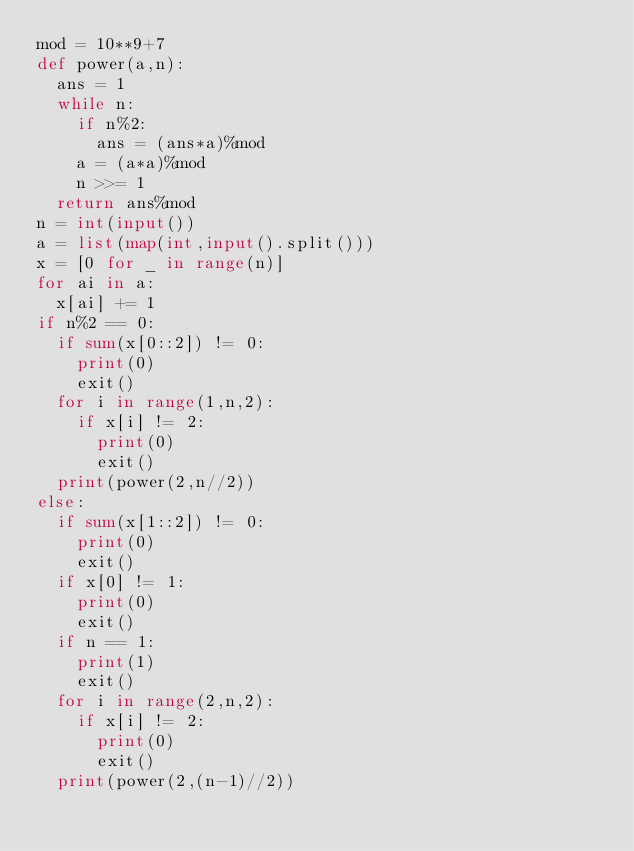<code> <loc_0><loc_0><loc_500><loc_500><_Python_>mod = 10**9+7
def power(a,n):
  ans = 1
  while n:
    if n%2:
      ans = (ans*a)%mod
    a = (a*a)%mod
    n >>= 1
  return ans%mod 
n = int(input())
a = list(map(int,input().split()))
x = [0 for _ in range(n)]
for ai in a:
  x[ai] += 1
if n%2 == 0:
  if sum(x[0::2]) != 0:
    print(0)
    exit()
  for i in range(1,n,2):
    if x[i] != 2:
      print(0)
      exit()
  print(power(2,n//2))
else:
  if sum(x[1::2]) != 0:
    print(0)
    exit()
  if x[0] != 1:
    print(0)
    exit()
  if n == 1:
    print(1)
    exit()
  for i in range(2,n,2):
    if x[i] != 2:
      print(0)
      exit()
  print(power(2,(n-1)//2))

</code> 